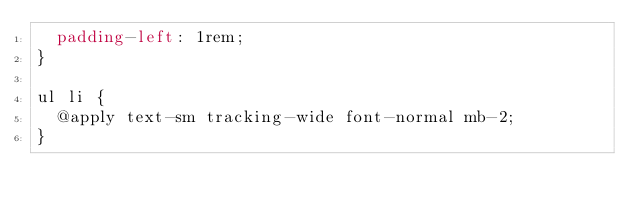Convert code to text. <code><loc_0><loc_0><loc_500><loc_500><_CSS_>  padding-left: 1rem;
}

ul li {
  @apply text-sm tracking-wide font-normal mb-2;
}
</code> 